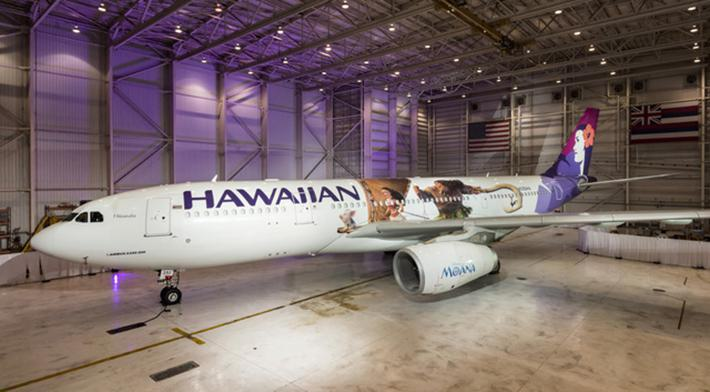What type of airplane is shown in the image? The airplane shown in the image is a commercial airliner, specifically designed for passenger travel. The large size and the jet engines are indicative of an aircraft used by airlines to carry passengers over long distances. 